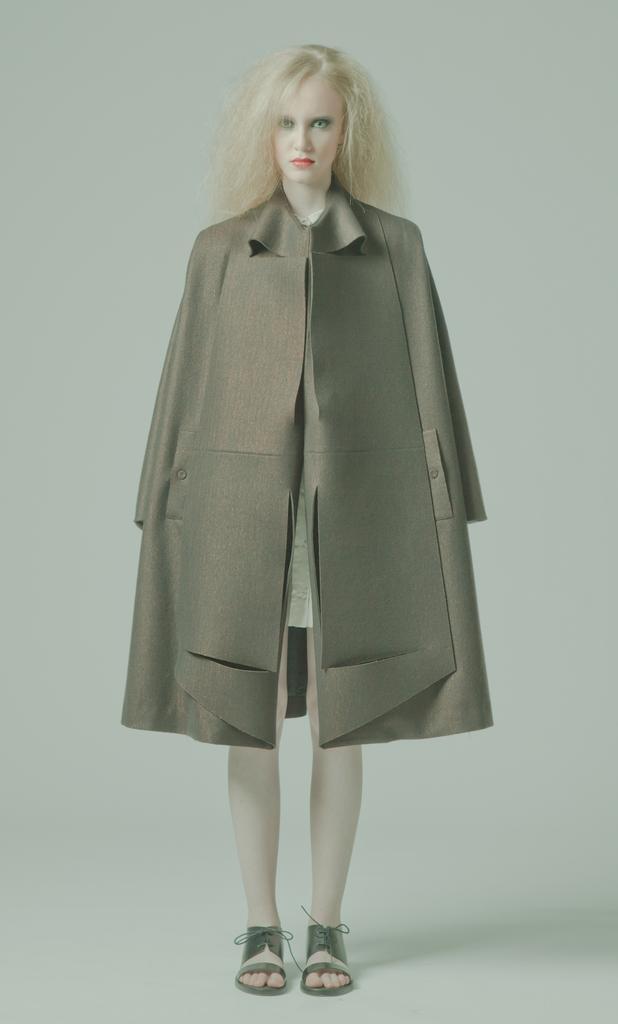Describe this image in one or two sentences. In the image there is a lady standing and she wore a jacket. 